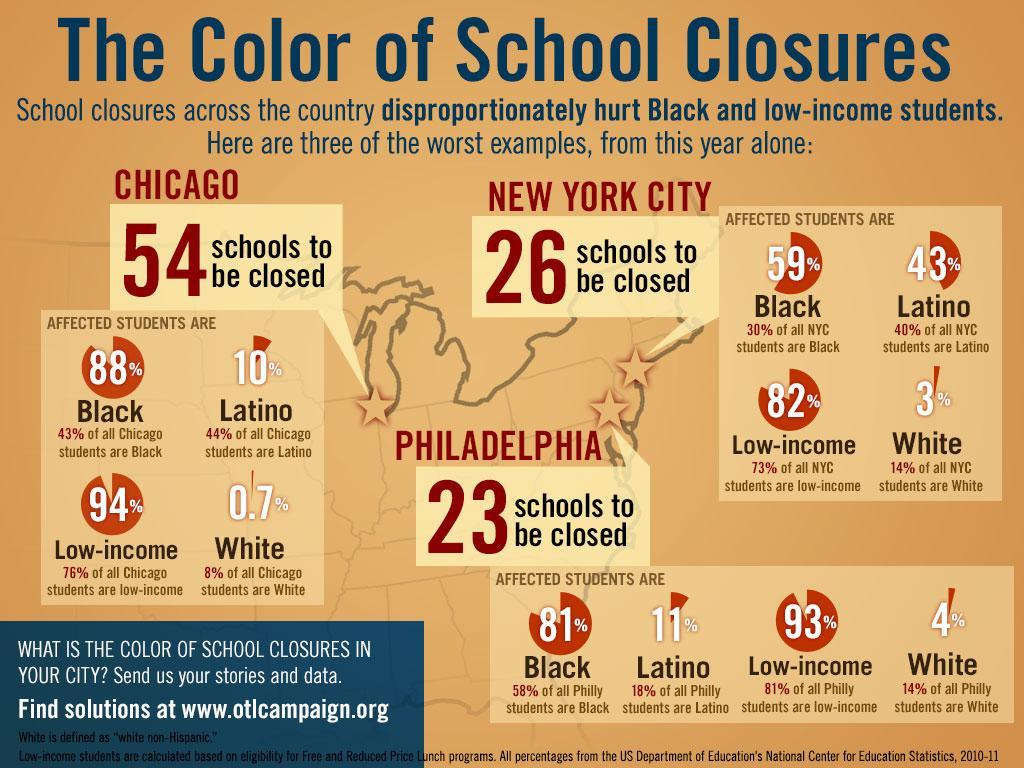What percentage of Latino students would be affected by the closure of schools in Philadelphia, 81%, 11%, or 93%?
Answer the question with a short phrase. 11% Which group of people would be least affected with closure of schools in Philadelphia? White What is the percentage of whites in all the students in New York city, 44%, 73%, or 14%? 14% What percentage of low income students are be affected by the closure of schools in Chicago, 94%, 0.7%, or 23%? 94% What is the percentage of blacks in all the students in Philadelphia, 18%, 81%, or 58%? 58% 